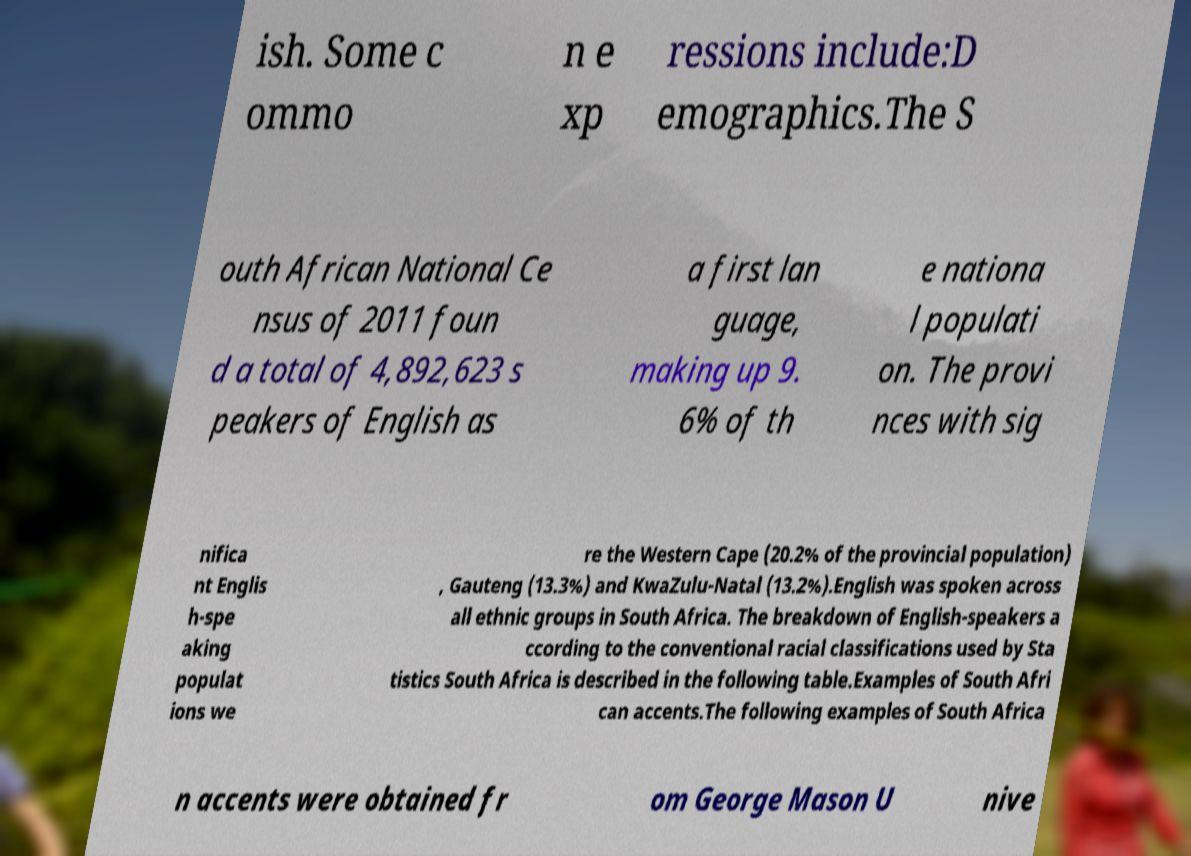Please identify and transcribe the text found in this image. ish. Some c ommo n e xp ressions include:D emographics.The S outh African National Ce nsus of 2011 foun d a total of 4,892,623 s peakers of English as a first lan guage, making up 9. 6% of th e nationa l populati on. The provi nces with sig nifica nt Englis h-spe aking populat ions we re the Western Cape (20.2% of the provincial population) , Gauteng (13.3%) and KwaZulu-Natal (13.2%).English was spoken across all ethnic groups in South Africa. The breakdown of English-speakers a ccording to the conventional racial classifications used by Sta tistics South Africa is described in the following table.Examples of South Afri can accents.The following examples of South Africa n accents were obtained fr om George Mason U nive 